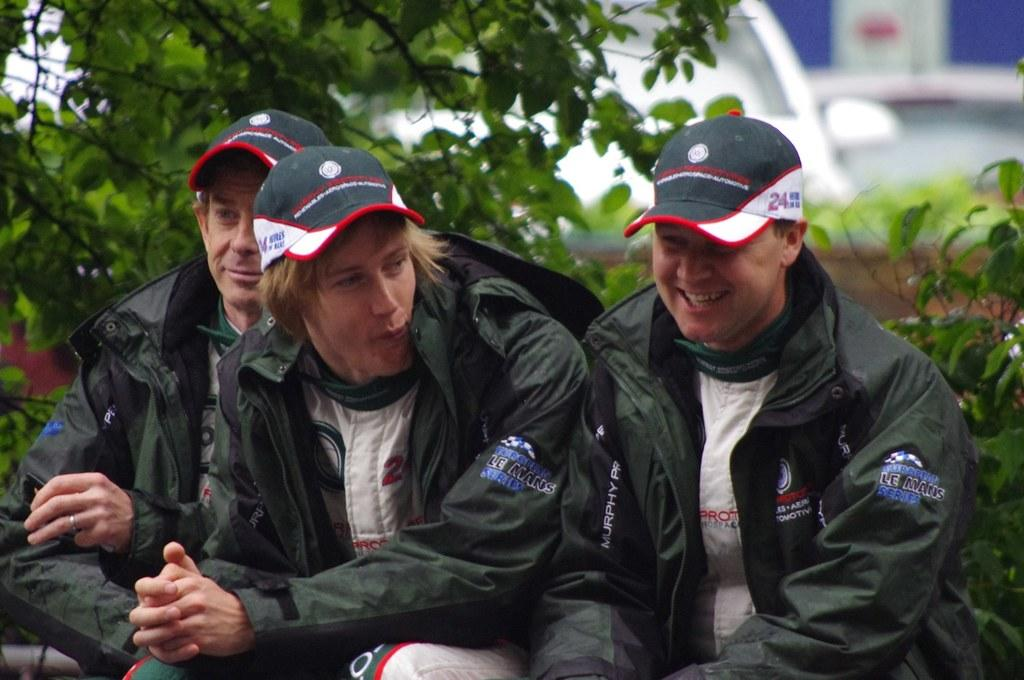How many people are in the image? There are three people in the image. What are the people doing in the image? The people are sitting. What are the people wearing on their heads? The people are wearing caps. What expression do the people have in the image? The people are smiling. What can be seen in the background of the image? There are plants in the background of the image. What colors can be seen in the image? The colors white and blue are present in the image. What word is being spelled out by the people in the image? There is no word being spelled out by the people in the image. 